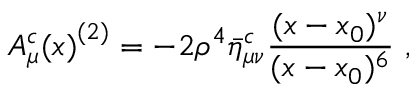Convert formula to latex. <formula><loc_0><loc_0><loc_500><loc_500>{ A _ { \mu } ^ { c } ( x ) } ^ { ( 2 ) } = - 2 \rho ^ { 4 } \bar { \eta } _ { \mu \nu } ^ { c } { \frac { ( x - x _ { 0 } ) ^ { \nu } } { ( x - x _ { 0 } ) ^ { 6 } } } ,</formula> 